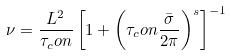<formula> <loc_0><loc_0><loc_500><loc_500>\nu = \frac { L ^ { 2 } } { \tau _ { c } o n } \left [ 1 + \left ( \tau _ { c } o n \frac { \bar { \sigma } } { 2 \pi } \right ) ^ { s } \right ] ^ { - 1 }</formula> 